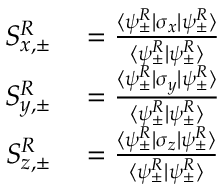Convert formula to latex. <formula><loc_0><loc_0><loc_500><loc_500>\begin{array} { r l } { S _ { x , \pm } ^ { R } } & = \frac { \langle \psi _ { \pm } ^ { R } | \sigma _ { x } | \psi _ { \pm } ^ { R } \rangle } { \langle \psi _ { \pm } ^ { R } | \psi _ { \pm } ^ { R } \rangle } } \\ { S _ { y , \pm } ^ { R } } & = \frac { \langle \psi _ { \pm } ^ { R } | \sigma _ { y } | \psi _ { \pm } ^ { R } \rangle } { \langle \psi _ { \pm } ^ { R } | \psi _ { \pm } ^ { R } \rangle } } \\ { S _ { z , \pm } ^ { R } } & = \frac { \langle \psi _ { \pm } ^ { R } | \sigma _ { z } | \psi _ { \pm } ^ { R } \rangle } { \langle \psi _ { \pm } ^ { R } | \psi _ { \pm } ^ { R } \rangle } } \end{array}</formula> 